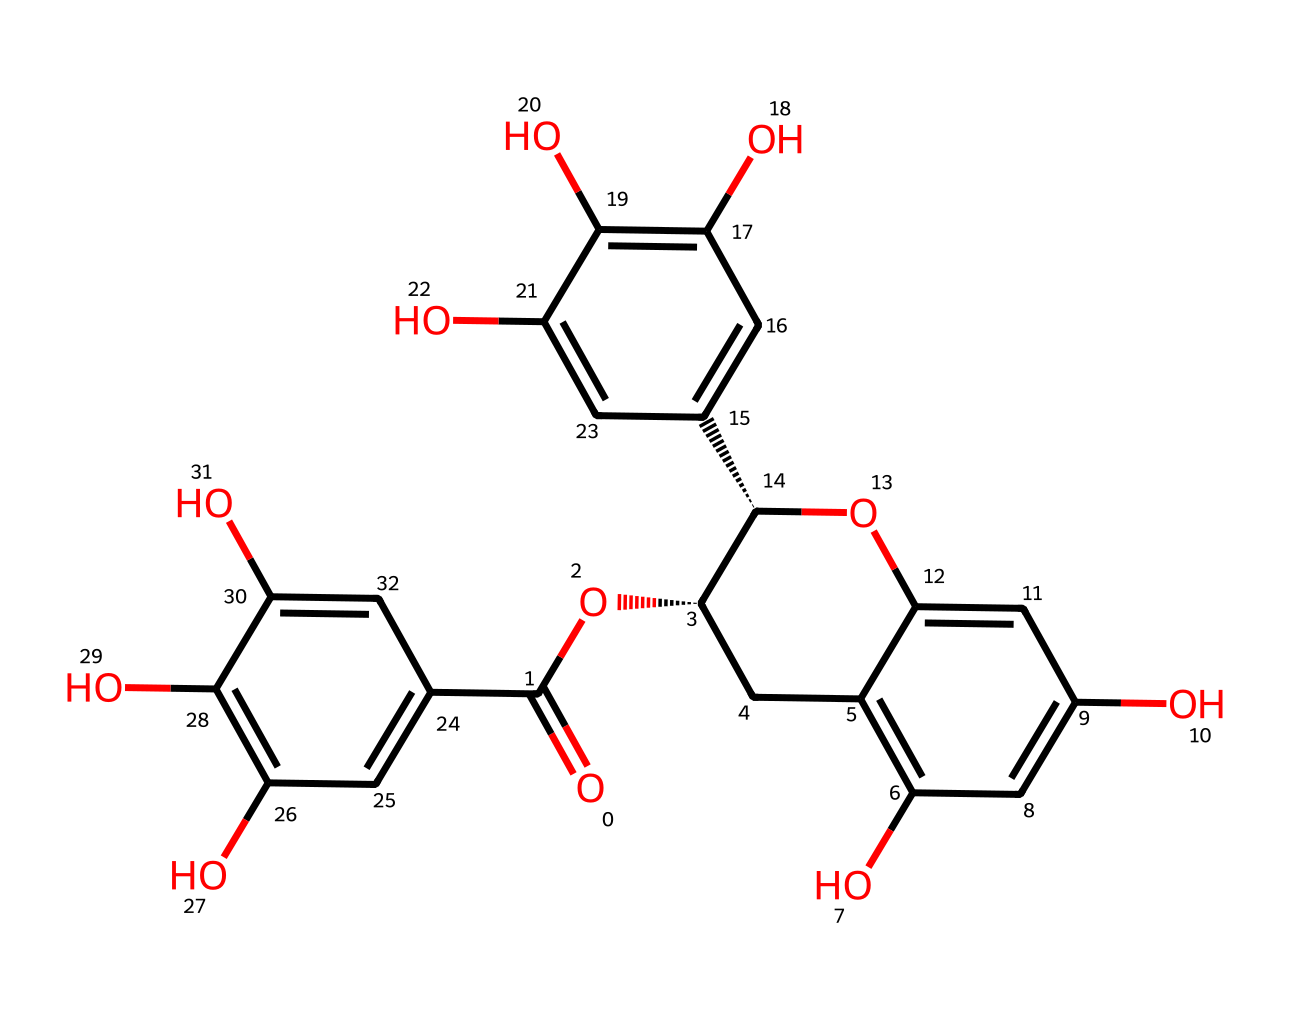how many carbon atoms are in epigallocatechin gallate? The SMILES representation includes several carbon atoms connected in various rings and chains. By counting each explicit carbon (C) and those implied by the structure, there are a total of 22 carbon atoms.
Answer: 22 what functional groups are present in epigallocatechin gallate? The presence of multiple hydroxyl (–OH) groups indicates that phenolic structures are present, along with an ester functional group from the carboxylic acid.
Answer: hydroxyl and ester what is the molecular formula of epigallocatechin gallate? By determining the count of carbon, hydrogen, and oxygen from the condensed structure present in the chemical, the molecular formula is deduced as C22H18O11.
Answer: C22H18O11 how many hydroxyl groups are present in epigallocatechin gallate? By analyzing the hydroxyl groups indicated in the SMILES, which display the presence of carbon atoms bonded to oxygen with a hydrogen, there are 5 hydroxyl groups present.
Answer: 5 is epigallocatechin gallate a phenolic compound? The structure clearly shows multiple hydroxyl groups attached to aromatic rings, which is characteristic of phenolic compounds.
Answer: yes which part of the molecule contributes to its antioxidant properties? The presence of multiple hydroxyl groups, particularly on the aromatic rings, enhances the ability to donate electrons, thus contributing to its antioxidant activities.
Answer: hydroxyl groups 